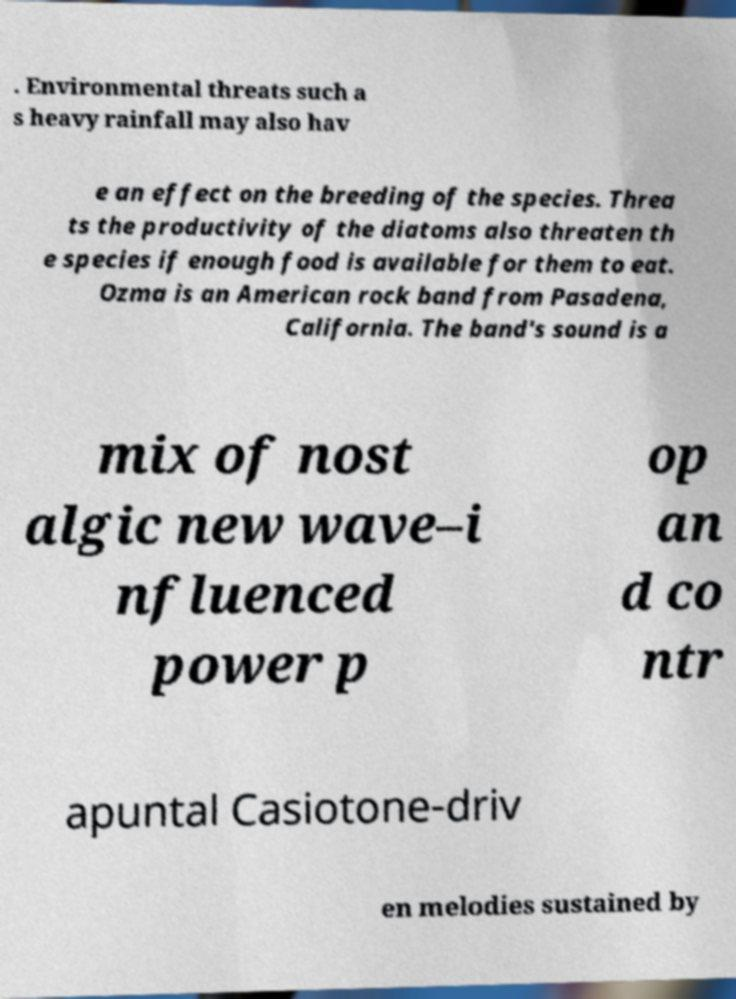I need the written content from this picture converted into text. Can you do that? . Environmental threats such a s heavy rainfall may also hav e an effect on the breeding of the species. Threa ts the productivity of the diatoms also threaten th e species if enough food is available for them to eat. Ozma is an American rock band from Pasadena, California. The band's sound is a mix of nost algic new wave–i nfluenced power p op an d co ntr apuntal Casiotone-driv en melodies sustained by 